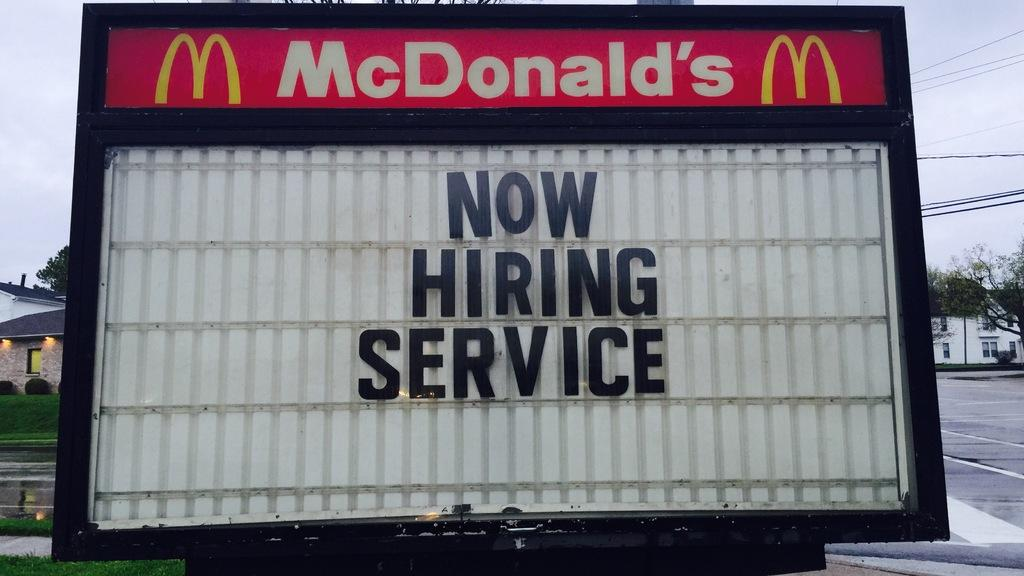<image>
Write a terse but informative summary of the picture. a mcdonalds billboard that says 'now hiring service' 